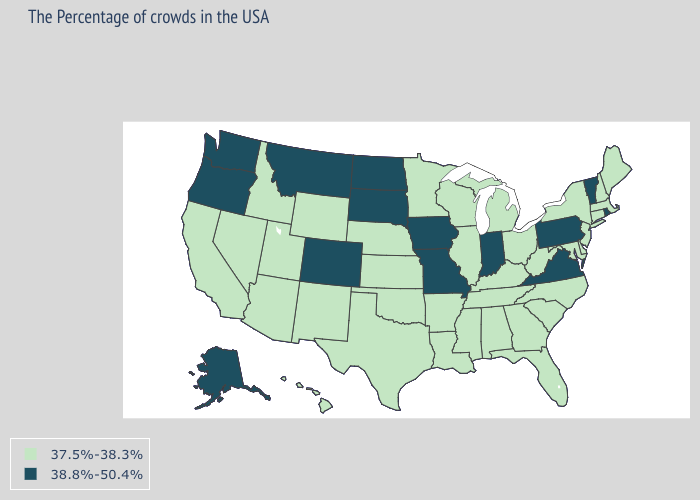Does Florida have the highest value in the South?
Answer briefly. No. Name the states that have a value in the range 37.5%-38.3%?
Keep it brief. Maine, Massachusetts, New Hampshire, Connecticut, New York, New Jersey, Delaware, Maryland, North Carolina, South Carolina, West Virginia, Ohio, Florida, Georgia, Michigan, Kentucky, Alabama, Tennessee, Wisconsin, Illinois, Mississippi, Louisiana, Arkansas, Minnesota, Kansas, Nebraska, Oklahoma, Texas, Wyoming, New Mexico, Utah, Arizona, Idaho, Nevada, California, Hawaii. Name the states that have a value in the range 37.5%-38.3%?
Quick response, please. Maine, Massachusetts, New Hampshire, Connecticut, New York, New Jersey, Delaware, Maryland, North Carolina, South Carolina, West Virginia, Ohio, Florida, Georgia, Michigan, Kentucky, Alabama, Tennessee, Wisconsin, Illinois, Mississippi, Louisiana, Arkansas, Minnesota, Kansas, Nebraska, Oklahoma, Texas, Wyoming, New Mexico, Utah, Arizona, Idaho, Nevada, California, Hawaii. How many symbols are there in the legend?
Short answer required. 2. Does North Carolina have a lower value than Missouri?
Keep it brief. Yes. Name the states that have a value in the range 37.5%-38.3%?
Be succinct. Maine, Massachusetts, New Hampshire, Connecticut, New York, New Jersey, Delaware, Maryland, North Carolina, South Carolina, West Virginia, Ohio, Florida, Georgia, Michigan, Kentucky, Alabama, Tennessee, Wisconsin, Illinois, Mississippi, Louisiana, Arkansas, Minnesota, Kansas, Nebraska, Oklahoma, Texas, Wyoming, New Mexico, Utah, Arizona, Idaho, Nevada, California, Hawaii. Name the states that have a value in the range 38.8%-50.4%?
Be succinct. Rhode Island, Vermont, Pennsylvania, Virginia, Indiana, Missouri, Iowa, South Dakota, North Dakota, Colorado, Montana, Washington, Oregon, Alaska. Which states have the highest value in the USA?
Be succinct. Rhode Island, Vermont, Pennsylvania, Virginia, Indiana, Missouri, Iowa, South Dakota, North Dakota, Colorado, Montana, Washington, Oregon, Alaska. Does Virginia have the highest value in the South?
Short answer required. Yes. Does Iowa have the highest value in the MidWest?
Keep it brief. Yes. What is the value of Alabama?
Concise answer only. 37.5%-38.3%. What is the lowest value in states that border New Mexico?
Concise answer only. 37.5%-38.3%. Name the states that have a value in the range 38.8%-50.4%?
Be succinct. Rhode Island, Vermont, Pennsylvania, Virginia, Indiana, Missouri, Iowa, South Dakota, North Dakota, Colorado, Montana, Washington, Oregon, Alaska. 